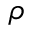Convert formula to latex. <formula><loc_0><loc_0><loc_500><loc_500>\rho</formula> 